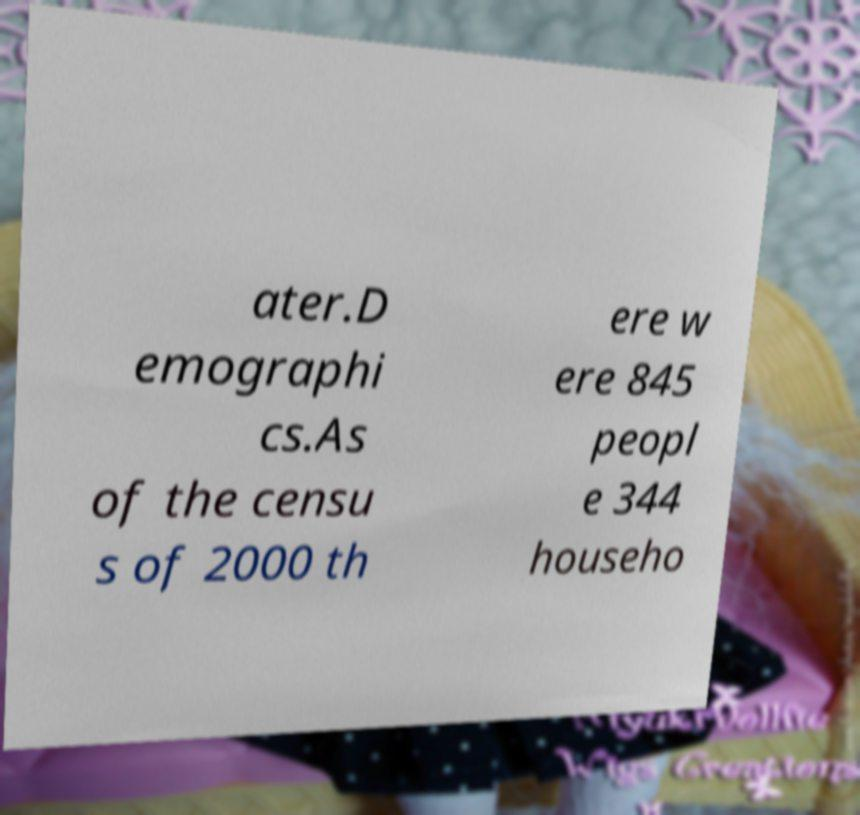Could you extract and type out the text from this image? ater.D emographi cs.As of the censu s of 2000 th ere w ere 845 peopl e 344 househo 